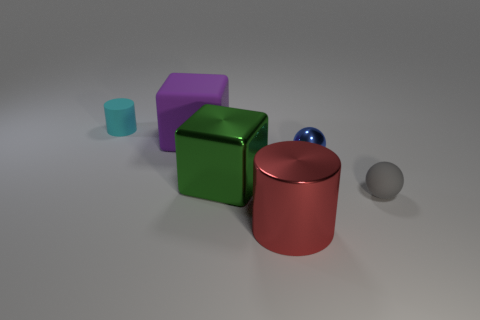What number of things are both behind the green metal cube and in front of the big purple thing?
Your answer should be compact. 1. Are there any other things that are the same color as the tiny cylinder?
Make the answer very short. No. What is the shape of the large purple thing that is the same material as the cyan cylinder?
Give a very brief answer. Cube. Is the gray thing the same size as the green metallic thing?
Give a very brief answer. No. Is the large cube that is in front of the blue ball made of the same material as the big purple thing?
Provide a succinct answer. No. There is a cylinder that is left of the cylinder on the right side of the cyan rubber cylinder; how many blue objects are on the right side of it?
Keep it short and to the point. 1. Does the rubber thing behind the large purple cube have the same shape as the big red metallic object?
Your response must be concise. Yes. What number of things are cubes or small spheres that are to the right of the big purple matte thing?
Your answer should be very brief. 4. Are there more tiny blue balls behind the big shiny block than large gray cylinders?
Make the answer very short. Yes. Is the number of blue objects on the left side of the big green metallic block the same as the number of cyan cylinders to the left of the large red object?
Make the answer very short. No. 